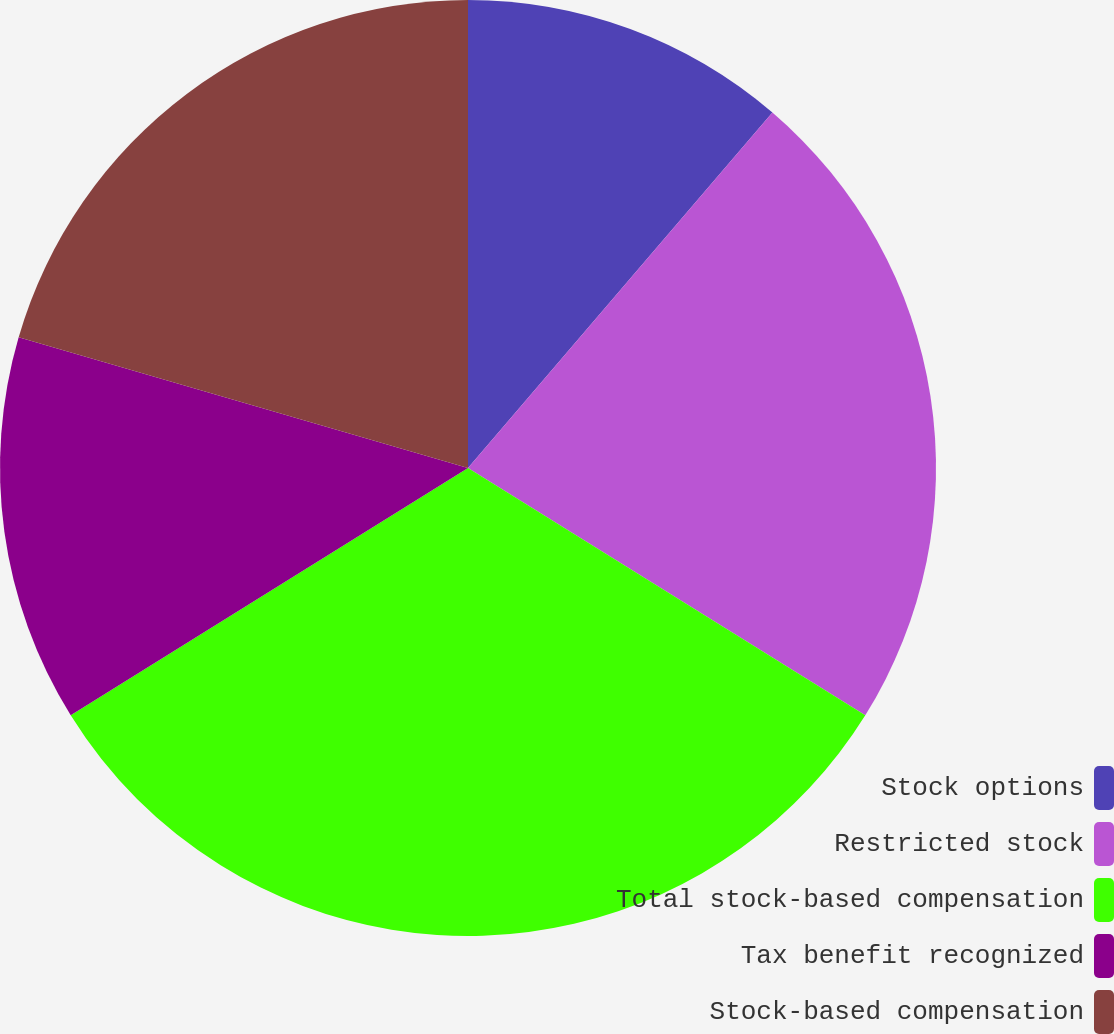Convert chart. <chart><loc_0><loc_0><loc_500><loc_500><pie_chart><fcel>Stock options<fcel>Restricted stock<fcel>Total stock-based compensation<fcel>Tax benefit recognized<fcel>Stock-based compensation<nl><fcel>11.27%<fcel>22.59%<fcel>32.27%<fcel>13.37%<fcel>20.49%<nl></chart> 